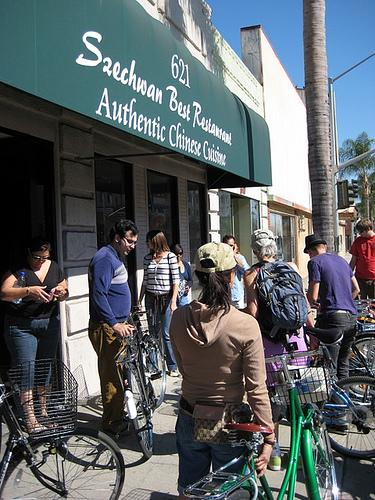What kind of food is most common in this restaurant? chinese 